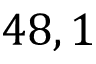<formula> <loc_0><loc_0><loc_500><loc_500>4 8 , 1</formula> 